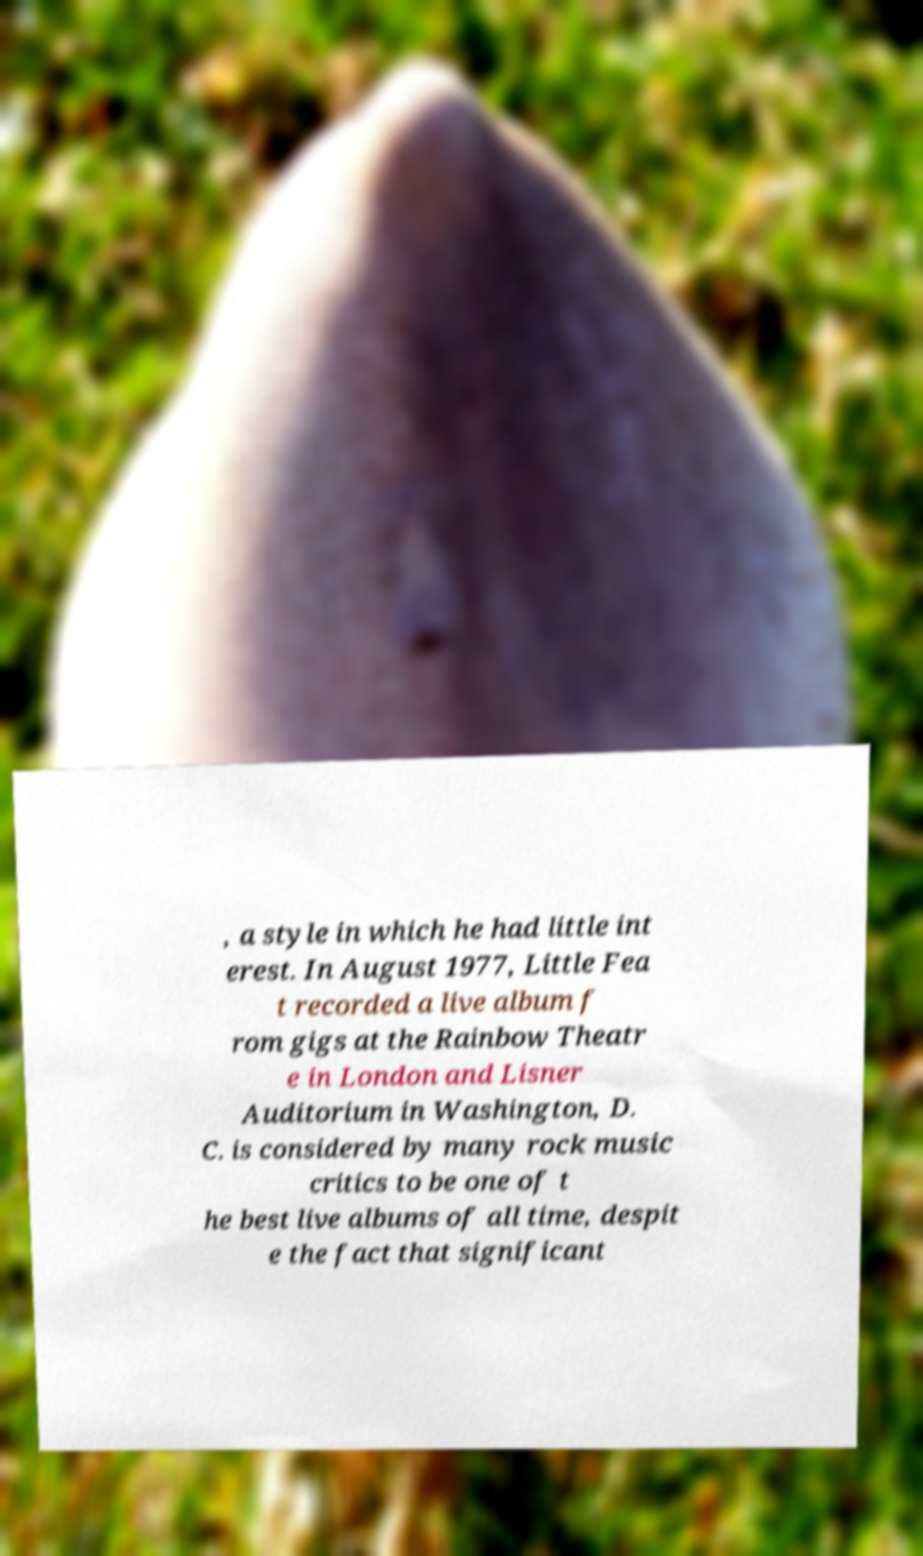For documentation purposes, I need the text within this image transcribed. Could you provide that? , a style in which he had little int erest. In August 1977, Little Fea t recorded a live album f rom gigs at the Rainbow Theatr e in London and Lisner Auditorium in Washington, D. C. is considered by many rock music critics to be one of t he best live albums of all time, despit e the fact that significant 